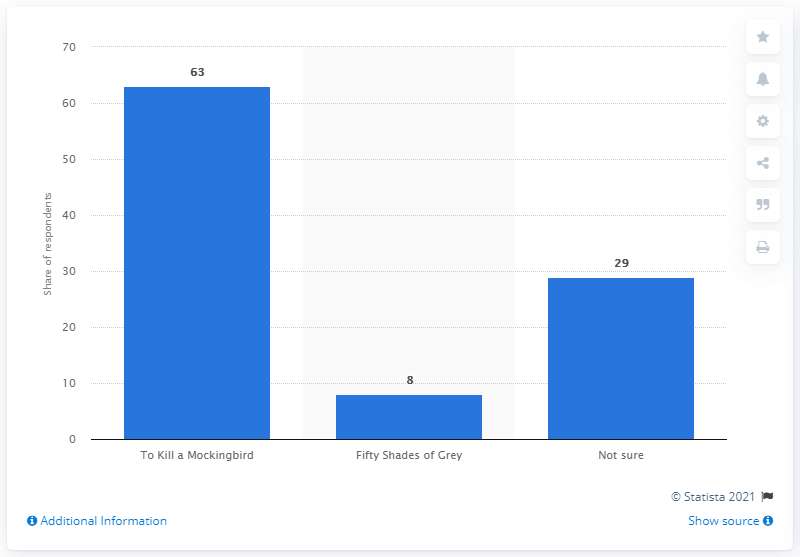Draw attention to some important aspects in this diagram. According to the response of 63% of respondents, To Kill A Mockingbird is considered to be a better literary work than Fifty Shades of Grey. 